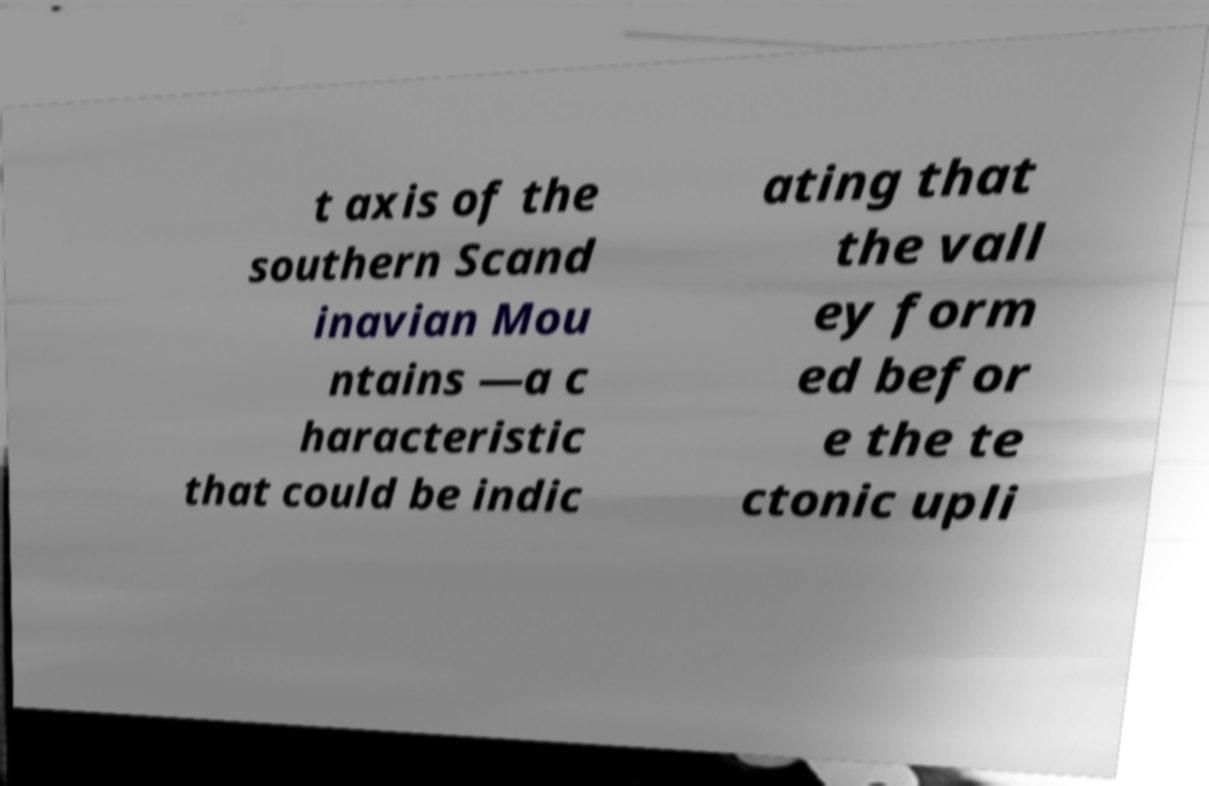Can you accurately transcribe the text from the provided image for me? t axis of the southern Scand inavian Mou ntains —a c haracteristic that could be indic ating that the vall ey form ed befor e the te ctonic upli 